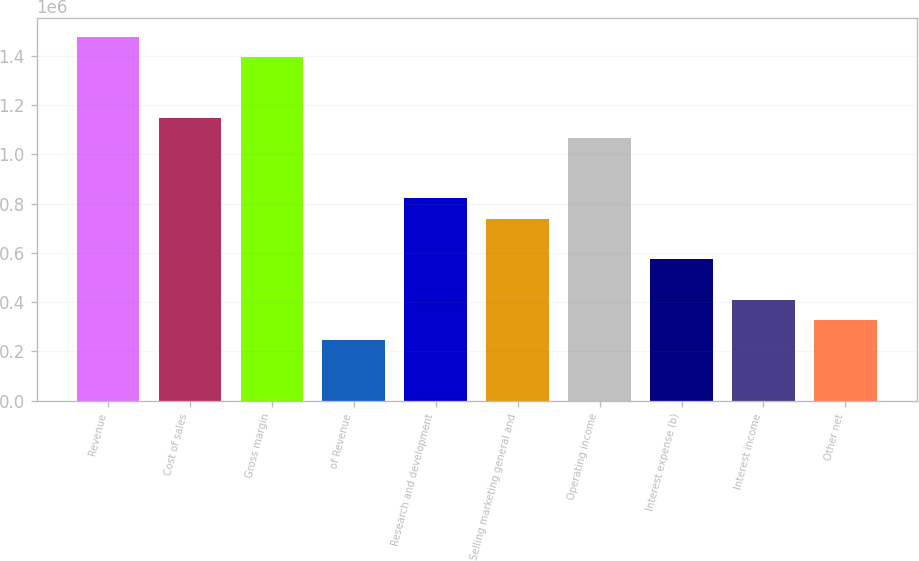Convert chart. <chart><loc_0><loc_0><loc_500><loc_500><bar_chart><fcel>Revenue<fcel>Cost of sales<fcel>Gross margin<fcel>of Revenue<fcel>Research and development<fcel>Selling marketing general and<fcel>Operating income<fcel>Interest expense (b)<fcel>Interest income<fcel>Other net<nl><fcel>1.47783e+06<fcel>1.14943e+06<fcel>1.39573e+06<fcel>246306<fcel>821019<fcel>738917<fcel>1.06732e+06<fcel>574713<fcel>410510<fcel>328408<nl></chart> 